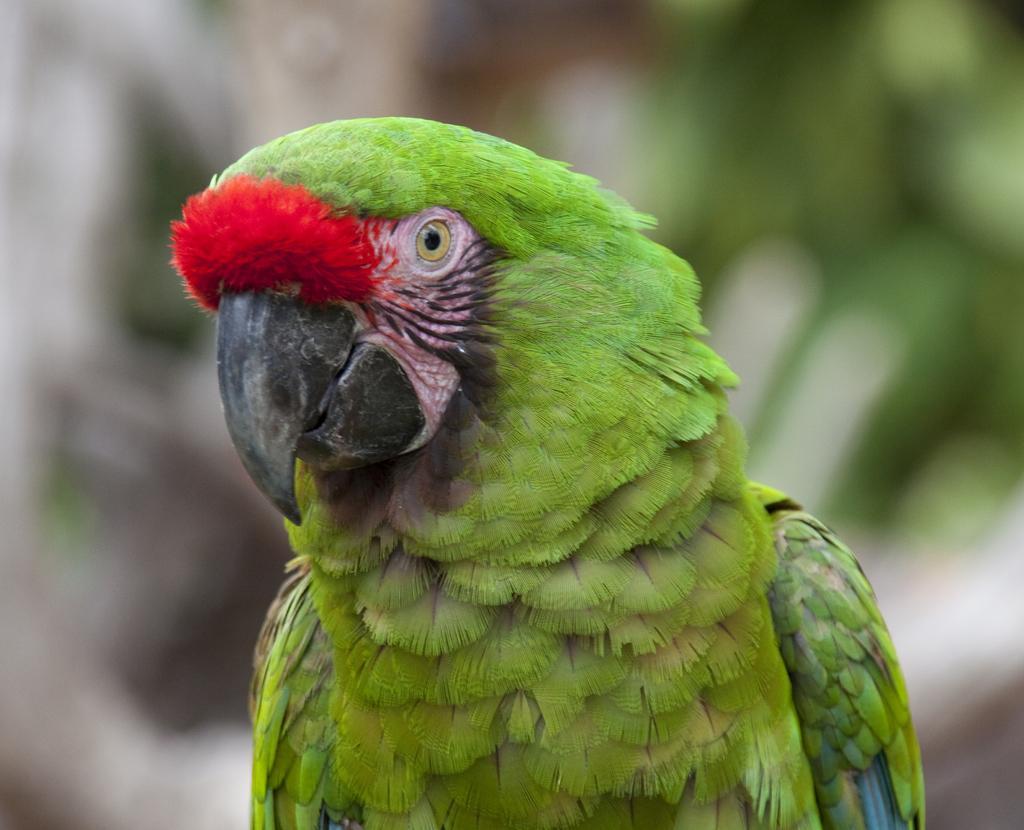Please provide a concise description of this image. In this image we can see a parrot. In the background the image is blur but we can see objects. 